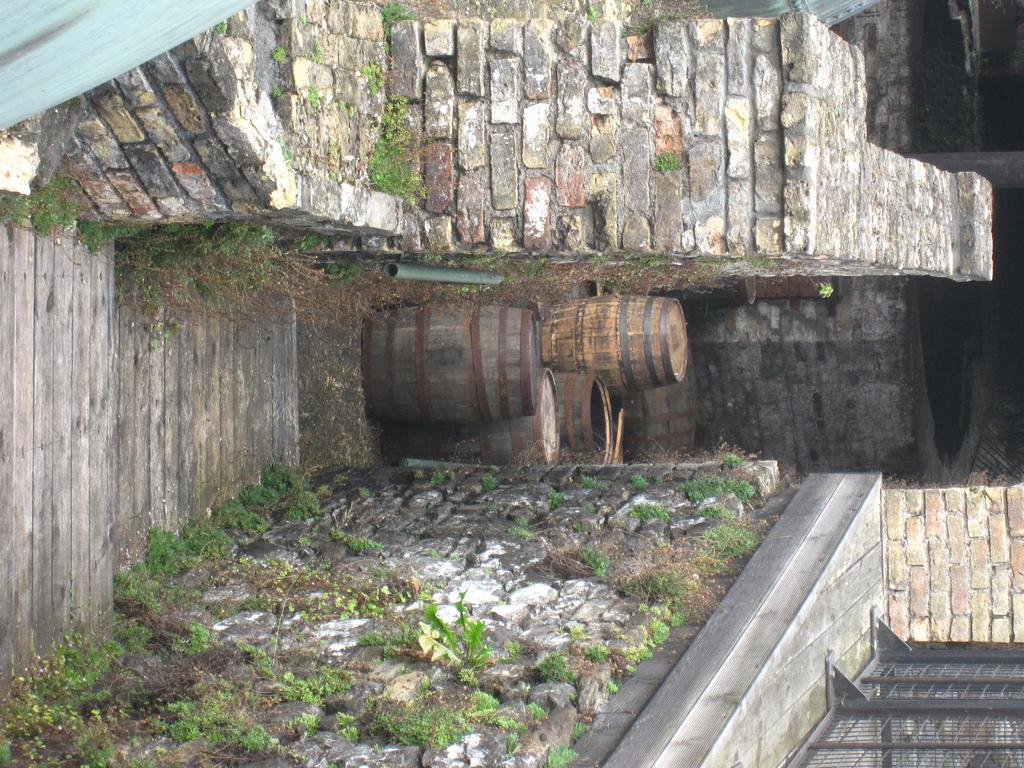What is the main structure in the center of the image? There is a staircase in the center of the image. What objects can be seen near the staircase? There are barrels in the image. What is visible in the background of the image? There is a wall at the background of the image. What is the overall layout of the space in the image? There are walls on both sides of the image. What type of marble is used for the staircase in the image? There is no mention of marble in the image, as the staircase appears to be made of a different material. Can you see a snail crawling on the barrels in the image? There is no snail present in the image; it only features a staircase, barrels, and walls. 